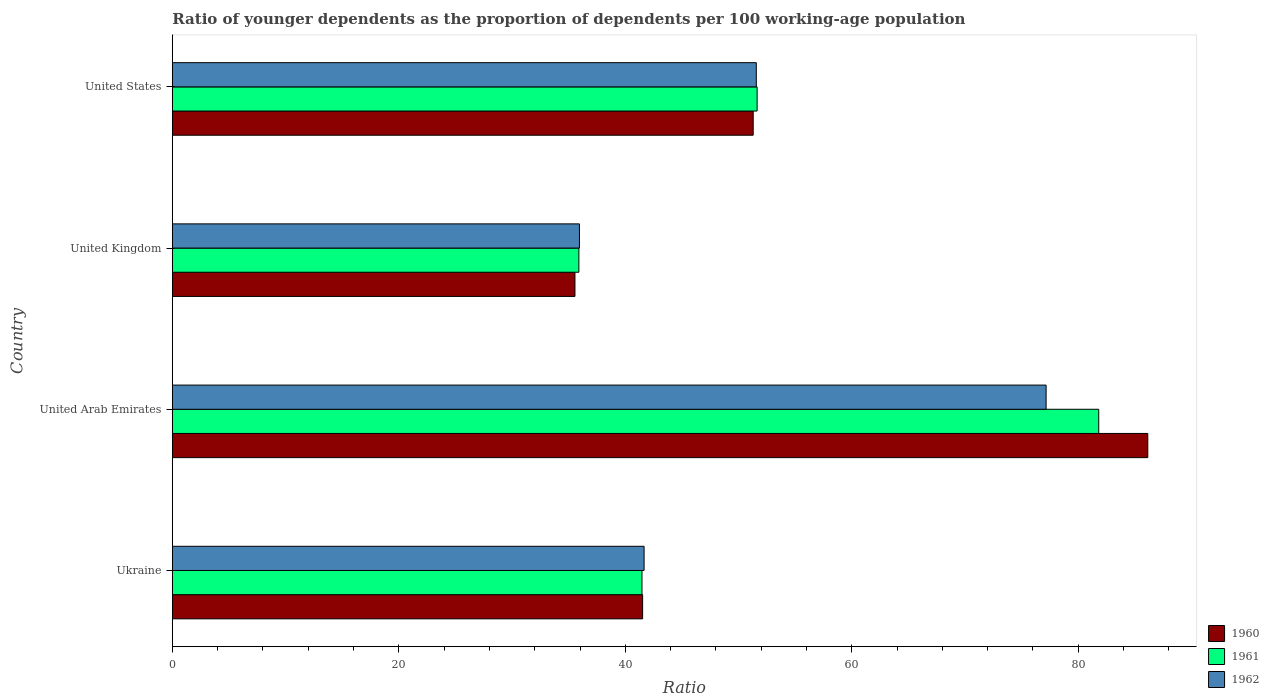How many different coloured bars are there?
Give a very brief answer. 3. Are the number of bars on each tick of the Y-axis equal?
Make the answer very short. Yes. How many bars are there on the 2nd tick from the top?
Your response must be concise. 3. How many bars are there on the 2nd tick from the bottom?
Make the answer very short. 3. What is the label of the 3rd group of bars from the top?
Offer a very short reply. United Arab Emirates. In how many cases, is the number of bars for a given country not equal to the number of legend labels?
Give a very brief answer. 0. What is the age dependency ratio(young) in 1962 in United Arab Emirates?
Offer a terse response. 77.16. Across all countries, what is the maximum age dependency ratio(young) in 1962?
Your answer should be compact. 77.16. Across all countries, what is the minimum age dependency ratio(young) in 1962?
Offer a very short reply. 35.95. In which country was the age dependency ratio(young) in 1962 maximum?
Ensure brevity in your answer.  United Arab Emirates. In which country was the age dependency ratio(young) in 1962 minimum?
Ensure brevity in your answer.  United Kingdom. What is the total age dependency ratio(young) in 1960 in the graph?
Give a very brief answer. 214.52. What is the difference between the age dependency ratio(young) in 1962 in Ukraine and that in United States?
Ensure brevity in your answer.  -9.91. What is the difference between the age dependency ratio(young) in 1962 in United Kingdom and the age dependency ratio(young) in 1961 in United States?
Make the answer very short. -15.69. What is the average age dependency ratio(young) in 1960 per country?
Ensure brevity in your answer.  53.63. What is the difference between the age dependency ratio(young) in 1960 and age dependency ratio(young) in 1962 in Ukraine?
Keep it short and to the point. -0.13. In how many countries, is the age dependency ratio(young) in 1961 greater than 36 ?
Provide a succinct answer. 3. What is the ratio of the age dependency ratio(young) in 1962 in Ukraine to that in United Arab Emirates?
Your answer should be compact. 0.54. Is the age dependency ratio(young) in 1962 in United Arab Emirates less than that in United Kingdom?
Ensure brevity in your answer.  No. Is the difference between the age dependency ratio(young) in 1960 in Ukraine and United Arab Emirates greater than the difference between the age dependency ratio(young) in 1962 in Ukraine and United Arab Emirates?
Offer a very short reply. No. What is the difference between the highest and the second highest age dependency ratio(young) in 1960?
Provide a short and direct response. 34.85. What is the difference between the highest and the lowest age dependency ratio(young) in 1962?
Your answer should be very brief. 41.21. In how many countries, is the age dependency ratio(young) in 1962 greater than the average age dependency ratio(young) in 1962 taken over all countries?
Your answer should be compact. 1. Is the sum of the age dependency ratio(young) in 1961 in Ukraine and United Kingdom greater than the maximum age dependency ratio(young) in 1960 across all countries?
Ensure brevity in your answer.  No. Is it the case that in every country, the sum of the age dependency ratio(young) in 1960 and age dependency ratio(young) in 1961 is greater than the age dependency ratio(young) in 1962?
Your answer should be compact. Yes. Are the values on the major ticks of X-axis written in scientific E-notation?
Give a very brief answer. No. Where does the legend appear in the graph?
Offer a very short reply. Bottom right. How are the legend labels stacked?
Offer a very short reply. Vertical. What is the title of the graph?
Offer a very short reply. Ratio of younger dependents as the proportion of dependents per 100 working-age population. Does "1973" appear as one of the legend labels in the graph?
Provide a short and direct response. No. What is the label or title of the X-axis?
Your answer should be very brief. Ratio. What is the label or title of the Y-axis?
Provide a short and direct response. Country. What is the Ratio of 1960 in Ukraine?
Ensure brevity in your answer.  41.53. What is the Ratio of 1961 in Ukraine?
Your answer should be very brief. 41.47. What is the Ratio of 1962 in Ukraine?
Offer a terse response. 41.66. What is the Ratio of 1960 in United Arab Emirates?
Offer a terse response. 86.14. What is the Ratio of 1961 in United Arab Emirates?
Provide a short and direct response. 81.81. What is the Ratio in 1962 in United Arab Emirates?
Provide a succinct answer. 77.16. What is the Ratio of 1960 in United Kingdom?
Offer a very short reply. 35.55. What is the Ratio in 1961 in United Kingdom?
Your answer should be compact. 35.9. What is the Ratio in 1962 in United Kingdom?
Give a very brief answer. 35.95. What is the Ratio in 1960 in United States?
Offer a terse response. 51.29. What is the Ratio of 1961 in United States?
Offer a very short reply. 51.64. What is the Ratio of 1962 in United States?
Provide a short and direct response. 51.57. Across all countries, what is the maximum Ratio of 1960?
Give a very brief answer. 86.14. Across all countries, what is the maximum Ratio in 1961?
Your response must be concise. 81.81. Across all countries, what is the maximum Ratio in 1962?
Provide a succinct answer. 77.16. Across all countries, what is the minimum Ratio of 1960?
Offer a very short reply. 35.55. Across all countries, what is the minimum Ratio of 1961?
Provide a short and direct response. 35.9. Across all countries, what is the minimum Ratio in 1962?
Ensure brevity in your answer.  35.95. What is the total Ratio of 1960 in the graph?
Your answer should be very brief. 214.52. What is the total Ratio in 1961 in the graph?
Offer a very short reply. 210.83. What is the total Ratio in 1962 in the graph?
Give a very brief answer. 206.35. What is the difference between the Ratio of 1960 in Ukraine and that in United Arab Emirates?
Offer a terse response. -44.61. What is the difference between the Ratio in 1961 in Ukraine and that in United Arab Emirates?
Your response must be concise. -40.34. What is the difference between the Ratio in 1962 in Ukraine and that in United Arab Emirates?
Offer a very short reply. -35.5. What is the difference between the Ratio in 1960 in Ukraine and that in United Kingdom?
Provide a short and direct response. 5.98. What is the difference between the Ratio in 1961 in Ukraine and that in United Kingdom?
Offer a terse response. 5.57. What is the difference between the Ratio of 1962 in Ukraine and that in United Kingdom?
Give a very brief answer. 5.71. What is the difference between the Ratio of 1960 in Ukraine and that in United States?
Keep it short and to the point. -9.76. What is the difference between the Ratio of 1961 in Ukraine and that in United States?
Provide a succinct answer. -10.17. What is the difference between the Ratio in 1962 in Ukraine and that in United States?
Provide a short and direct response. -9.91. What is the difference between the Ratio of 1960 in United Arab Emirates and that in United Kingdom?
Your response must be concise. 50.59. What is the difference between the Ratio of 1961 in United Arab Emirates and that in United Kingdom?
Your answer should be compact. 45.91. What is the difference between the Ratio in 1962 in United Arab Emirates and that in United Kingdom?
Offer a very short reply. 41.21. What is the difference between the Ratio of 1960 in United Arab Emirates and that in United States?
Ensure brevity in your answer.  34.85. What is the difference between the Ratio of 1961 in United Arab Emirates and that in United States?
Keep it short and to the point. 30.17. What is the difference between the Ratio in 1962 in United Arab Emirates and that in United States?
Provide a succinct answer. 25.59. What is the difference between the Ratio in 1960 in United Kingdom and that in United States?
Provide a succinct answer. -15.74. What is the difference between the Ratio in 1961 in United Kingdom and that in United States?
Provide a succinct answer. -15.74. What is the difference between the Ratio of 1962 in United Kingdom and that in United States?
Give a very brief answer. -15.62. What is the difference between the Ratio in 1960 in Ukraine and the Ratio in 1961 in United Arab Emirates?
Provide a succinct answer. -40.28. What is the difference between the Ratio in 1960 in Ukraine and the Ratio in 1962 in United Arab Emirates?
Give a very brief answer. -35.63. What is the difference between the Ratio of 1961 in Ukraine and the Ratio of 1962 in United Arab Emirates?
Provide a short and direct response. -35.69. What is the difference between the Ratio of 1960 in Ukraine and the Ratio of 1961 in United Kingdom?
Your response must be concise. 5.63. What is the difference between the Ratio in 1960 in Ukraine and the Ratio in 1962 in United Kingdom?
Keep it short and to the point. 5.58. What is the difference between the Ratio of 1961 in Ukraine and the Ratio of 1962 in United Kingdom?
Offer a very short reply. 5.52. What is the difference between the Ratio in 1960 in Ukraine and the Ratio in 1961 in United States?
Give a very brief answer. -10.11. What is the difference between the Ratio in 1960 in Ukraine and the Ratio in 1962 in United States?
Provide a succinct answer. -10.04. What is the difference between the Ratio in 1961 in Ukraine and the Ratio in 1962 in United States?
Give a very brief answer. -10.1. What is the difference between the Ratio of 1960 in United Arab Emirates and the Ratio of 1961 in United Kingdom?
Keep it short and to the point. 50.24. What is the difference between the Ratio of 1960 in United Arab Emirates and the Ratio of 1962 in United Kingdom?
Provide a short and direct response. 50.19. What is the difference between the Ratio in 1961 in United Arab Emirates and the Ratio in 1962 in United Kingdom?
Offer a terse response. 45.86. What is the difference between the Ratio in 1960 in United Arab Emirates and the Ratio in 1961 in United States?
Your answer should be compact. 34.5. What is the difference between the Ratio of 1960 in United Arab Emirates and the Ratio of 1962 in United States?
Your answer should be compact. 34.57. What is the difference between the Ratio in 1961 in United Arab Emirates and the Ratio in 1962 in United States?
Your answer should be compact. 30.24. What is the difference between the Ratio of 1960 in United Kingdom and the Ratio of 1961 in United States?
Offer a terse response. -16.09. What is the difference between the Ratio in 1960 in United Kingdom and the Ratio in 1962 in United States?
Give a very brief answer. -16.02. What is the difference between the Ratio of 1961 in United Kingdom and the Ratio of 1962 in United States?
Make the answer very short. -15.67. What is the average Ratio of 1960 per country?
Offer a terse response. 53.63. What is the average Ratio of 1961 per country?
Your answer should be compact. 52.71. What is the average Ratio in 1962 per country?
Provide a short and direct response. 51.59. What is the difference between the Ratio in 1960 and Ratio in 1961 in Ukraine?
Keep it short and to the point. 0.06. What is the difference between the Ratio of 1960 and Ratio of 1962 in Ukraine?
Offer a very short reply. -0.13. What is the difference between the Ratio of 1961 and Ratio of 1962 in Ukraine?
Your answer should be very brief. -0.19. What is the difference between the Ratio of 1960 and Ratio of 1961 in United Arab Emirates?
Provide a short and direct response. 4.33. What is the difference between the Ratio in 1960 and Ratio in 1962 in United Arab Emirates?
Your response must be concise. 8.98. What is the difference between the Ratio of 1961 and Ratio of 1962 in United Arab Emirates?
Ensure brevity in your answer.  4.65. What is the difference between the Ratio in 1960 and Ratio in 1961 in United Kingdom?
Your answer should be compact. -0.35. What is the difference between the Ratio of 1960 and Ratio of 1962 in United Kingdom?
Make the answer very short. -0.4. What is the difference between the Ratio in 1961 and Ratio in 1962 in United Kingdom?
Give a very brief answer. -0.05. What is the difference between the Ratio in 1960 and Ratio in 1961 in United States?
Provide a succinct answer. -0.35. What is the difference between the Ratio of 1960 and Ratio of 1962 in United States?
Offer a very short reply. -0.28. What is the difference between the Ratio in 1961 and Ratio in 1962 in United States?
Ensure brevity in your answer.  0.07. What is the ratio of the Ratio in 1960 in Ukraine to that in United Arab Emirates?
Your answer should be compact. 0.48. What is the ratio of the Ratio of 1961 in Ukraine to that in United Arab Emirates?
Offer a terse response. 0.51. What is the ratio of the Ratio in 1962 in Ukraine to that in United Arab Emirates?
Give a very brief answer. 0.54. What is the ratio of the Ratio of 1960 in Ukraine to that in United Kingdom?
Provide a succinct answer. 1.17. What is the ratio of the Ratio in 1961 in Ukraine to that in United Kingdom?
Your answer should be very brief. 1.16. What is the ratio of the Ratio of 1962 in Ukraine to that in United Kingdom?
Provide a succinct answer. 1.16. What is the ratio of the Ratio in 1960 in Ukraine to that in United States?
Make the answer very short. 0.81. What is the ratio of the Ratio in 1961 in Ukraine to that in United States?
Your answer should be very brief. 0.8. What is the ratio of the Ratio of 1962 in Ukraine to that in United States?
Provide a short and direct response. 0.81. What is the ratio of the Ratio of 1960 in United Arab Emirates to that in United Kingdom?
Give a very brief answer. 2.42. What is the ratio of the Ratio of 1961 in United Arab Emirates to that in United Kingdom?
Give a very brief answer. 2.28. What is the ratio of the Ratio of 1962 in United Arab Emirates to that in United Kingdom?
Offer a very short reply. 2.15. What is the ratio of the Ratio in 1960 in United Arab Emirates to that in United States?
Your answer should be compact. 1.68. What is the ratio of the Ratio in 1961 in United Arab Emirates to that in United States?
Make the answer very short. 1.58. What is the ratio of the Ratio in 1962 in United Arab Emirates to that in United States?
Offer a very short reply. 1.5. What is the ratio of the Ratio of 1960 in United Kingdom to that in United States?
Make the answer very short. 0.69. What is the ratio of the Ratio in 1961 in United Kingdom to that in United States?
Ensure brevity in your answer.  0.7. What is the ratio of the Ratio in 1962 in United Kingdom to that in United States?
Provide a short and direct response. 0.7. What is the difference between the highest and the second highest Ratio in 1960?
Provide a short and direct response. 34.85. What is the difference between the highest and the second highest Ratio in 1961?
Your answer should be compact. 30.17. What is the difference between the highest and the second highest Ratio of 1962?
Your answer should be very brief. 25.59. What is the difference between the highest and the lowest Ratio of 1960?
Offer a terse response. 50.59. What is the difference between the highest and the lowest Ratio of 1961?
Keep it short and to the point. 45.91. What is the difference between the highest and the lowest Ratio of 1962?
Ensure brevity in your answer.  41.21. 